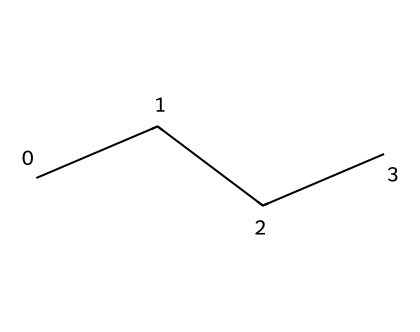What is the name of the chemical represented by this structure? The SMILES notation "CCCC" corresponds to four carbon atoms connected in a chain, which identifies it as butane.
Answer: butane How many carbon atoms are in this chemical structure? The structure consists of four carbon atoms, as indicated by the four 'C' symbols in the SMILES representation.
Answer: four How many hydrogen atoms are attached to this molecule? Each carbon atom in butane typically bonds with enough hydrogen atoms to have four total bonds. Thus, with four carbon atoms, there are ten hydrogen atoms (C4H10).
Answer: ten What type of bonding is primarily present in this compound? The structure of butane shows only single bonds between carbon atoms and between carbon and hydrogen, indicating it has predominantly covalent bonding.
Answer: covalent Is this chemical compound a gas at room temperature? Butane is classified as a gas under standard temperature and pressure conditions, which aligns with its properties as an aliphatic compound.
Answer: gas What is the primary use of butane in disposable lighters? Butane is used as a fuel in disposable lighters due to its high flammability and efficiency in combustion, making it ideal for quick ignition.
Answer: fuel 